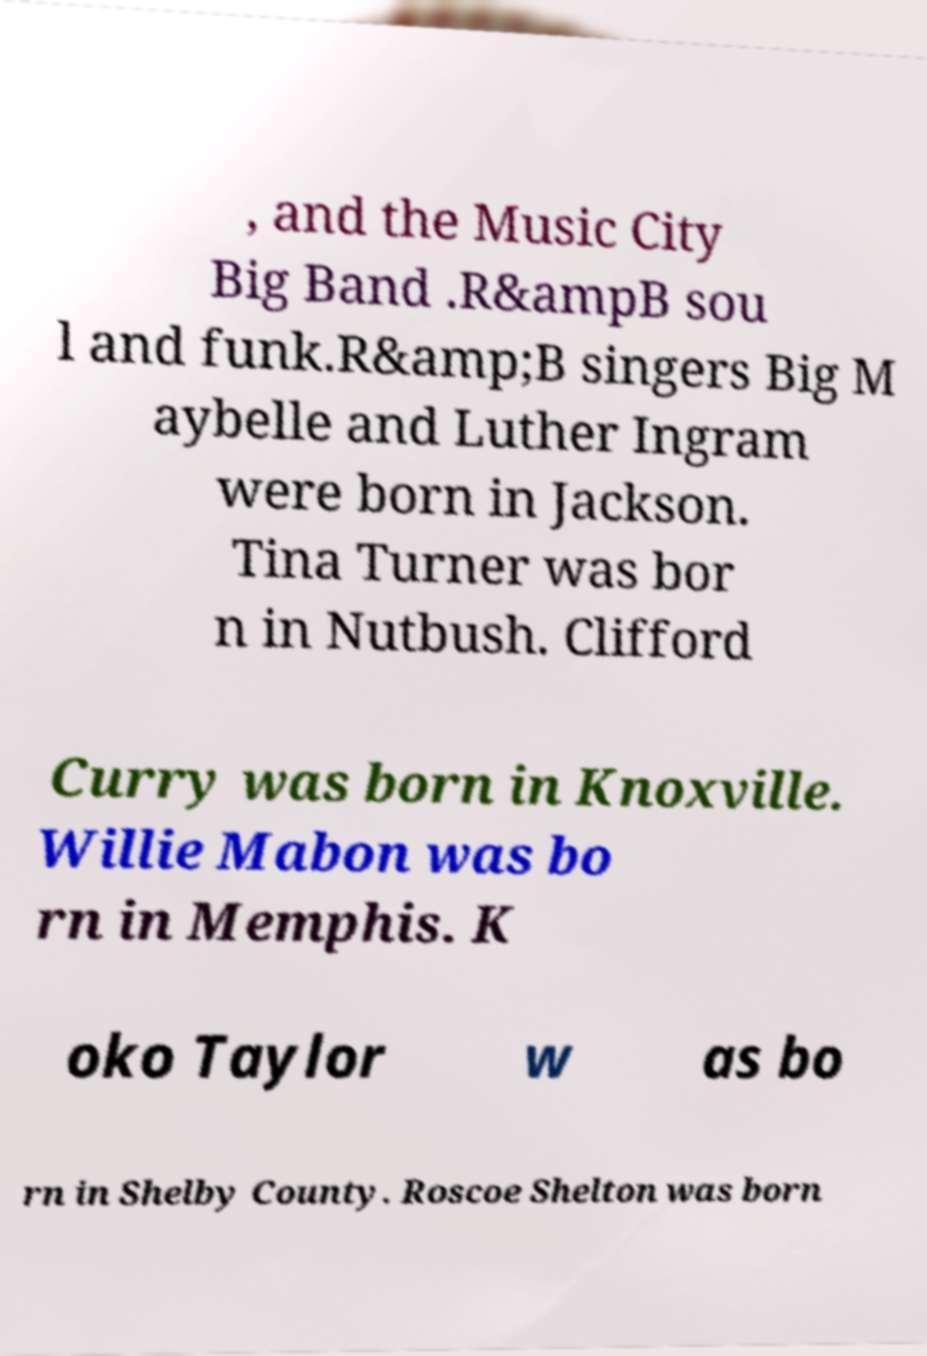Can you read and provide the text displayed in the image?This photo seems to have some interesting text. Can you extract and type it out for me? , and the Music City Big Band .R&ampB sou l and funk.R&amp;B singers Big M aybelle and Luther Ingram were born in Jackson. Tina Turner was bor n in Nutbush. Clifford Curry was born in Knoxville. Willie Mabon was bo rn in Memphis. K oko Taylor w as bo rn in Shelby County. Roscoe Shelton was born 